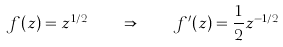Convert formula to latex. <formula><loc_0><loc_0><loc_500><loc_500>f ( z ) = z ^ { 1 / 2 } \quad \Rightarrow \quad f ^ { \prime } ( z ) = { \frac { 1 } { 2 } } z ^ { - 1 / 2 }</formula> 